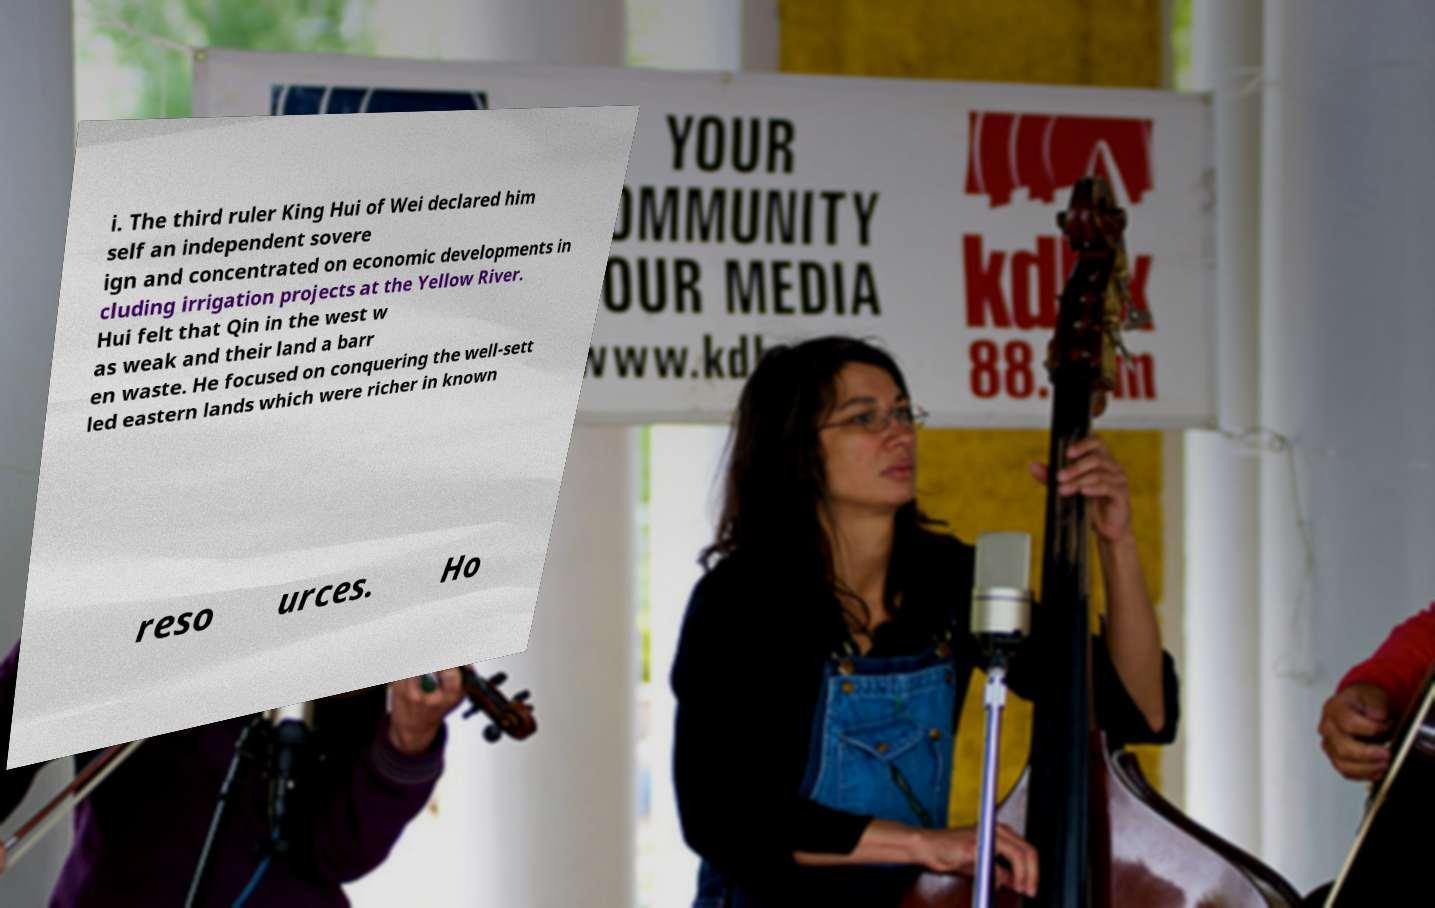There's text embedded in this image that I need extracted. Can you transcribe it verbatim? i. The third ruler King Hui of Wei declared him self an independent sovere ign and concentrated on economic developments in cluding irrigation projects at the Yellow River. Hui felt that Qin in the west w as weak and their land a barr en waste. He focused on conquering the well-sett led eastern lands which were richer in known reso urces. Ho 